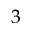<formula> <loc_0><loc_0><loc_500><loc_500>3</formula> 